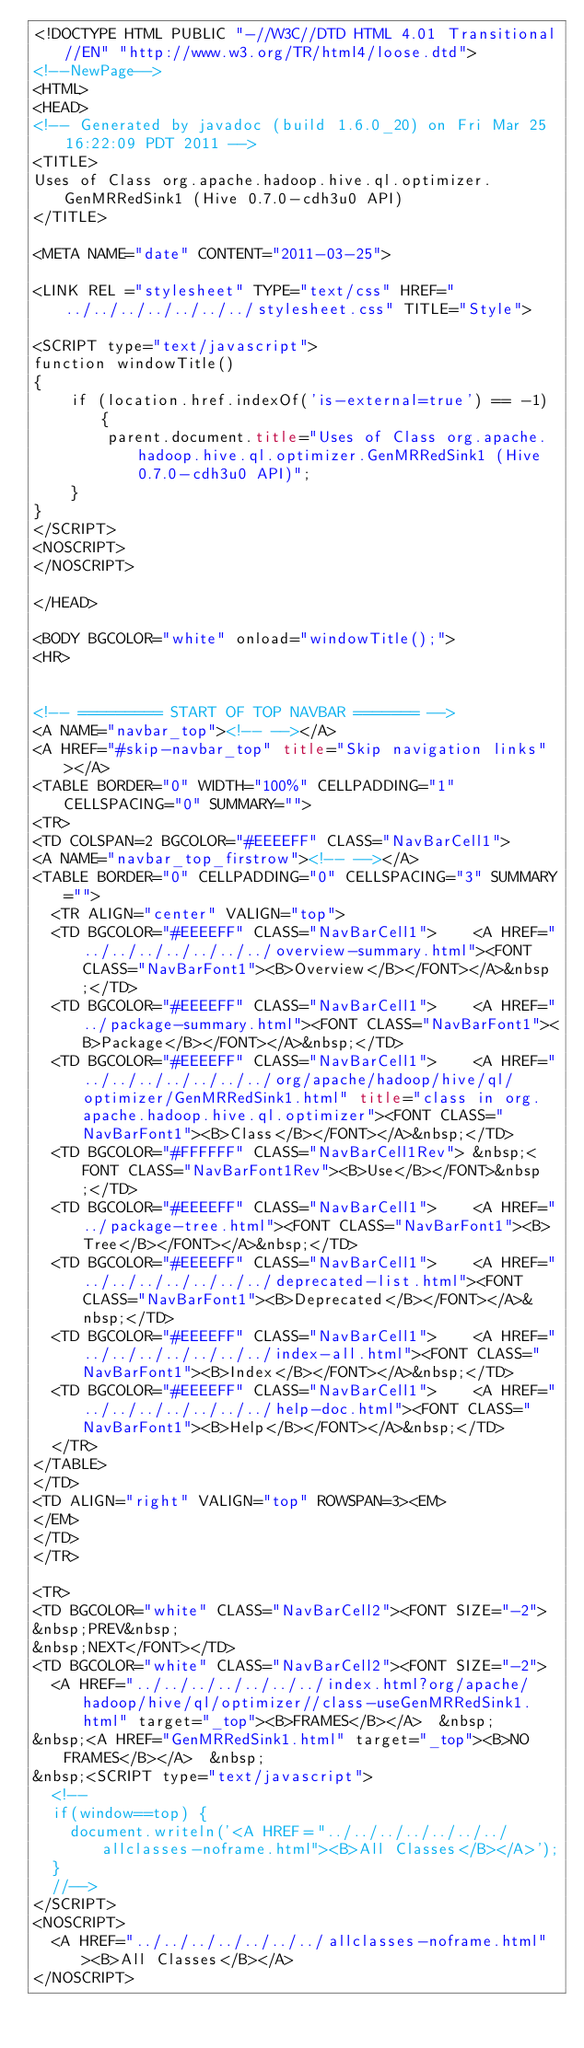Convert code to text. <code><loc_0><loc_0><loc_500><loc_500><_HTML_><!DOCTYPE HTML PUBLIC "-//W3C//DTD HTML 4.01 Transitional//EN" "http://www.w3.org/TR/html4/loose.dtd">
<!--NewPage-->
<HTML>
<HEAD>
<!-- Generated by javadoc (build 1.6.0_20) on Fri Mar 25 16:22:09 PDT 2011 -->
<TITLE>
Uses of Class org.apache.hadoop.hive.ql.optimizer.GenMRRedSink1 (Hive 0.7.0-cdh3u0 API)
</TITLE>

<META NAME="date" CONTENT="2011-03-25">

<LINK REL ="stylesheet" TYPE="text/css" HREF="../../../../../../../stylesheet.css" TITLE="Style">

<SCRIPT type="text/javascript">
function windowTitle()
{
    if (location.href.indexOf('is-external=true') == -1) {
        parent.document.title="Uses of Class org.apache.hadoop.hive.ql.optimizer.GenMRRedSink1 (Hive 0.7.0-cdh3u0 API)";
    }
}
</SCRIPT>
<NOSCRIPT>
</NOSCRIPT>

</HEAD>

<BODY BGCOLOR="white" onload="windowTitle();">
<HR>


<!-- ========= START OF TOP NAVBAR ======= -->
<A NAME="navbar_top"><!-- --></A>
<A HREF="#skip-navbar_top" title="Skip navigation links"></A>
<TABLE BORDER="0" WIDTH="100%" CELLPADDING="1" CELLSPACING="0" SUMMARY="">
<TR>
<TD COLSPAN=2 BGCOLOR="#EEEEFF" CLASS="NavBarCell1">
<A NAME="navbar_top_firstrow"><!-- --></A>
<TABLE BORDER="0" CELLPADDING="0" CELLSPACING="3" SUMMARY="">
  <TR ALIGN="center" VALIGN="top">
  <TD BGCOLOR="#EEEEFF" CLASS="NavBarCell1">    <A HREF="../../../../../../../overview-summary.html"><FONT CLASS="NavBarFont1"><B>Overview</B></FONT></A>&nbsp;</TD>
  <TD BGCOLOR="#EEEEFF" CLASS="NavBarCell1">    <A HREF="../package-summary.html"><FONT CLASS="NavBarFont1"><B>Package</B></FONT></A>&nbsp;</TD>
  <TD BGCOLOR="#EEEEFF" CLASS="NavBarCell1">    <A HREF="../../../../../../../org/apache/hadoop/hive/ql/optimizer/GenMRRedSink1.html" title="class in org.apache.hadoop.hive.ql.optimizer"><FONT CLASS="NavBarFont1"><B>Class</B></FONT></A>&nbsp;</TD>
  <TD BGCOLOR="#FFFFFF" CLASS="NavBarCell1Rev"> &nbsp;<FONT CLASS="NavBarFont1Rev"><B>Use</B></FONT>&nbsp;</TD>
  <TD BGCOLOR="#EEEEFF" CLASS="NavBarCell1">    <A HREF="../package-tree.html"><FONT CLASS="NavBarFont1"><B>Tree</B></FONT></A>&nbsp;</TD>
  <TD BGCOLOR="#EEEEFF" CLASS="NavBarCell1">    <A HREF="../../../../../../../deprecated-list.html"><FONT CLASS="NavBarFont1"><B>Deprecated</B></FONT></A>&nbsp;</TD>
  <TD BGCOLOR="#EEEEFF" CLASS="NavBarCell1">    <A HREF="../../../../../../../index-all.html"><FONT CLASS="NavBarFont1"><B>Index</B></FONT></A>&nbsp;</TD>
  <TD BGCOLOR="#EEEEFF" CLASS="NavBarCell1">    <A HREF="../../../../../../../help-doc.html"><FONT CLASS="NavBarFont1"><B>Help</B></FONT></A>&nbsp;</TD>
  </TR>
</TABLE>
</TD>
<TD ALIGN="right" VALIGN="top" ROWSPAN=3><EM>
</EM>
</TD>
</TR>

<TR>
<TD BGCOLOR="white" CLASS="NavBarCell2"><FONT SIZE="-2">
&nbsp;PREV&nbsp;
&nbsp;NEXT</FONT></TD>
<TD BGCOLOR="white" CLASS="NavBarCell2"><FONT SIZE="-2">
  <A HREF="../../../../../../../index.html?org/apache/hadoop/hive/ql/optimizer//class-useGenMRRedSink1.html" target="_top"><B>FRAMES</B></A>  &nbsp;
&nbsp;<A HREF="GenMRRedSink1.html" target="_top"><B>NO FRAMES</B></A>  &nbsp;
&nbsp;<SCRIPT type="text/javascript">
  <!--
  if(window==top) {
    document.writeln('<A HREF="../../../../../../../allclasses-noframe.html"><B>All Classes</B></A>');
  }
  //-->
</SCRIPT>
<NOSCRIPT>
  <A HREF="../../../../../../../allclasses-noframe.html"><B>All Classes</B></A>
</NOSCRIPT>

</code> 